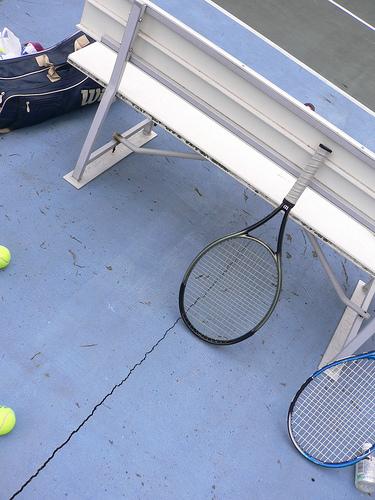How many tennis rackets are there?
Concise answer only. 2. Are the tennis rackets made of wood?
Keep it brief. No. Are these tennis rackets worn out?
Keep it brief. No. 